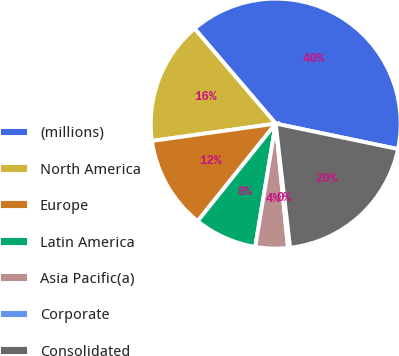Convert chart. <chart><loc_0><loc_0><loc_500><loc_500><pie_chart><fcel>(millions)<fcel>North America<fcel>Europe<fcel>Latin America<fcel>Asia Pacific(a)<fcel>Corporate<fcel>Consolidated<nl><fcel>39.51%<fcel>15.97%<fcel>12.04%<fcel>8.12%<fcel>4.19%<fcel>0.27%<fcel>19.89%<nl></chart> 